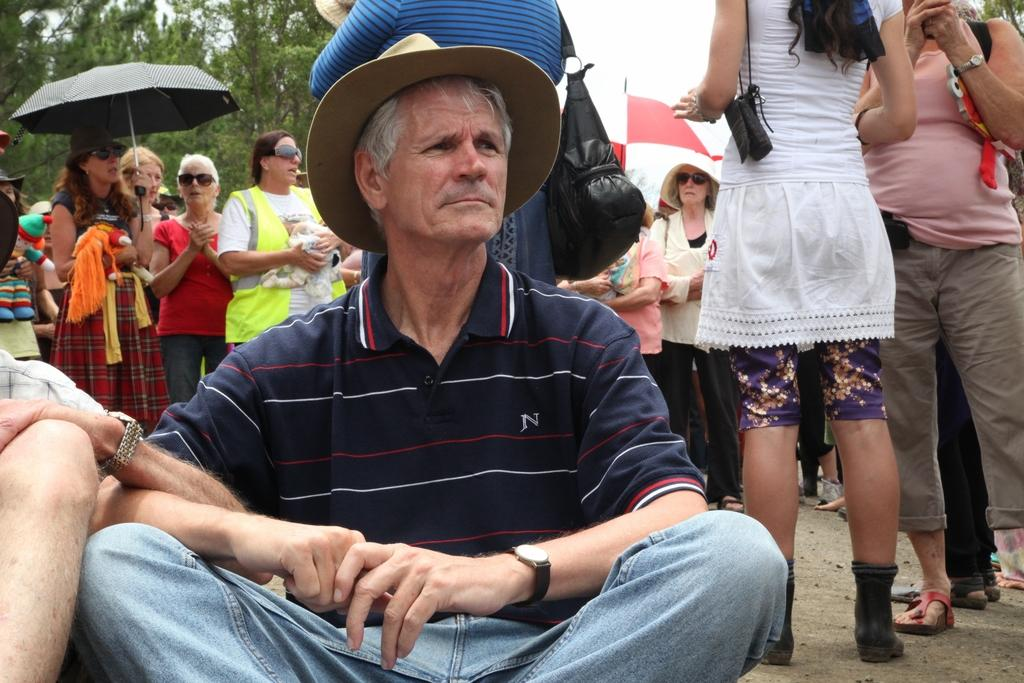How many people are in the image? There is a group of people in the image, but the exact number is not specified. What are the people in the image doing? Some people are standing, while others are sitting. What can be seen in the background of the image? There are trees and the sky visible in the background of the image. What are some people using to protect themselves from the elements? Some people are holding umbrellas. What type of fork can be seen in the hands of the band members in the image? There is no band or fork present in the image; it features a group of people with some holding umbrellas. What is the visibility like in the image due to the mist? There is no mention of mist in the image, and visibility appears to be clear based on the visible trees and sky. 